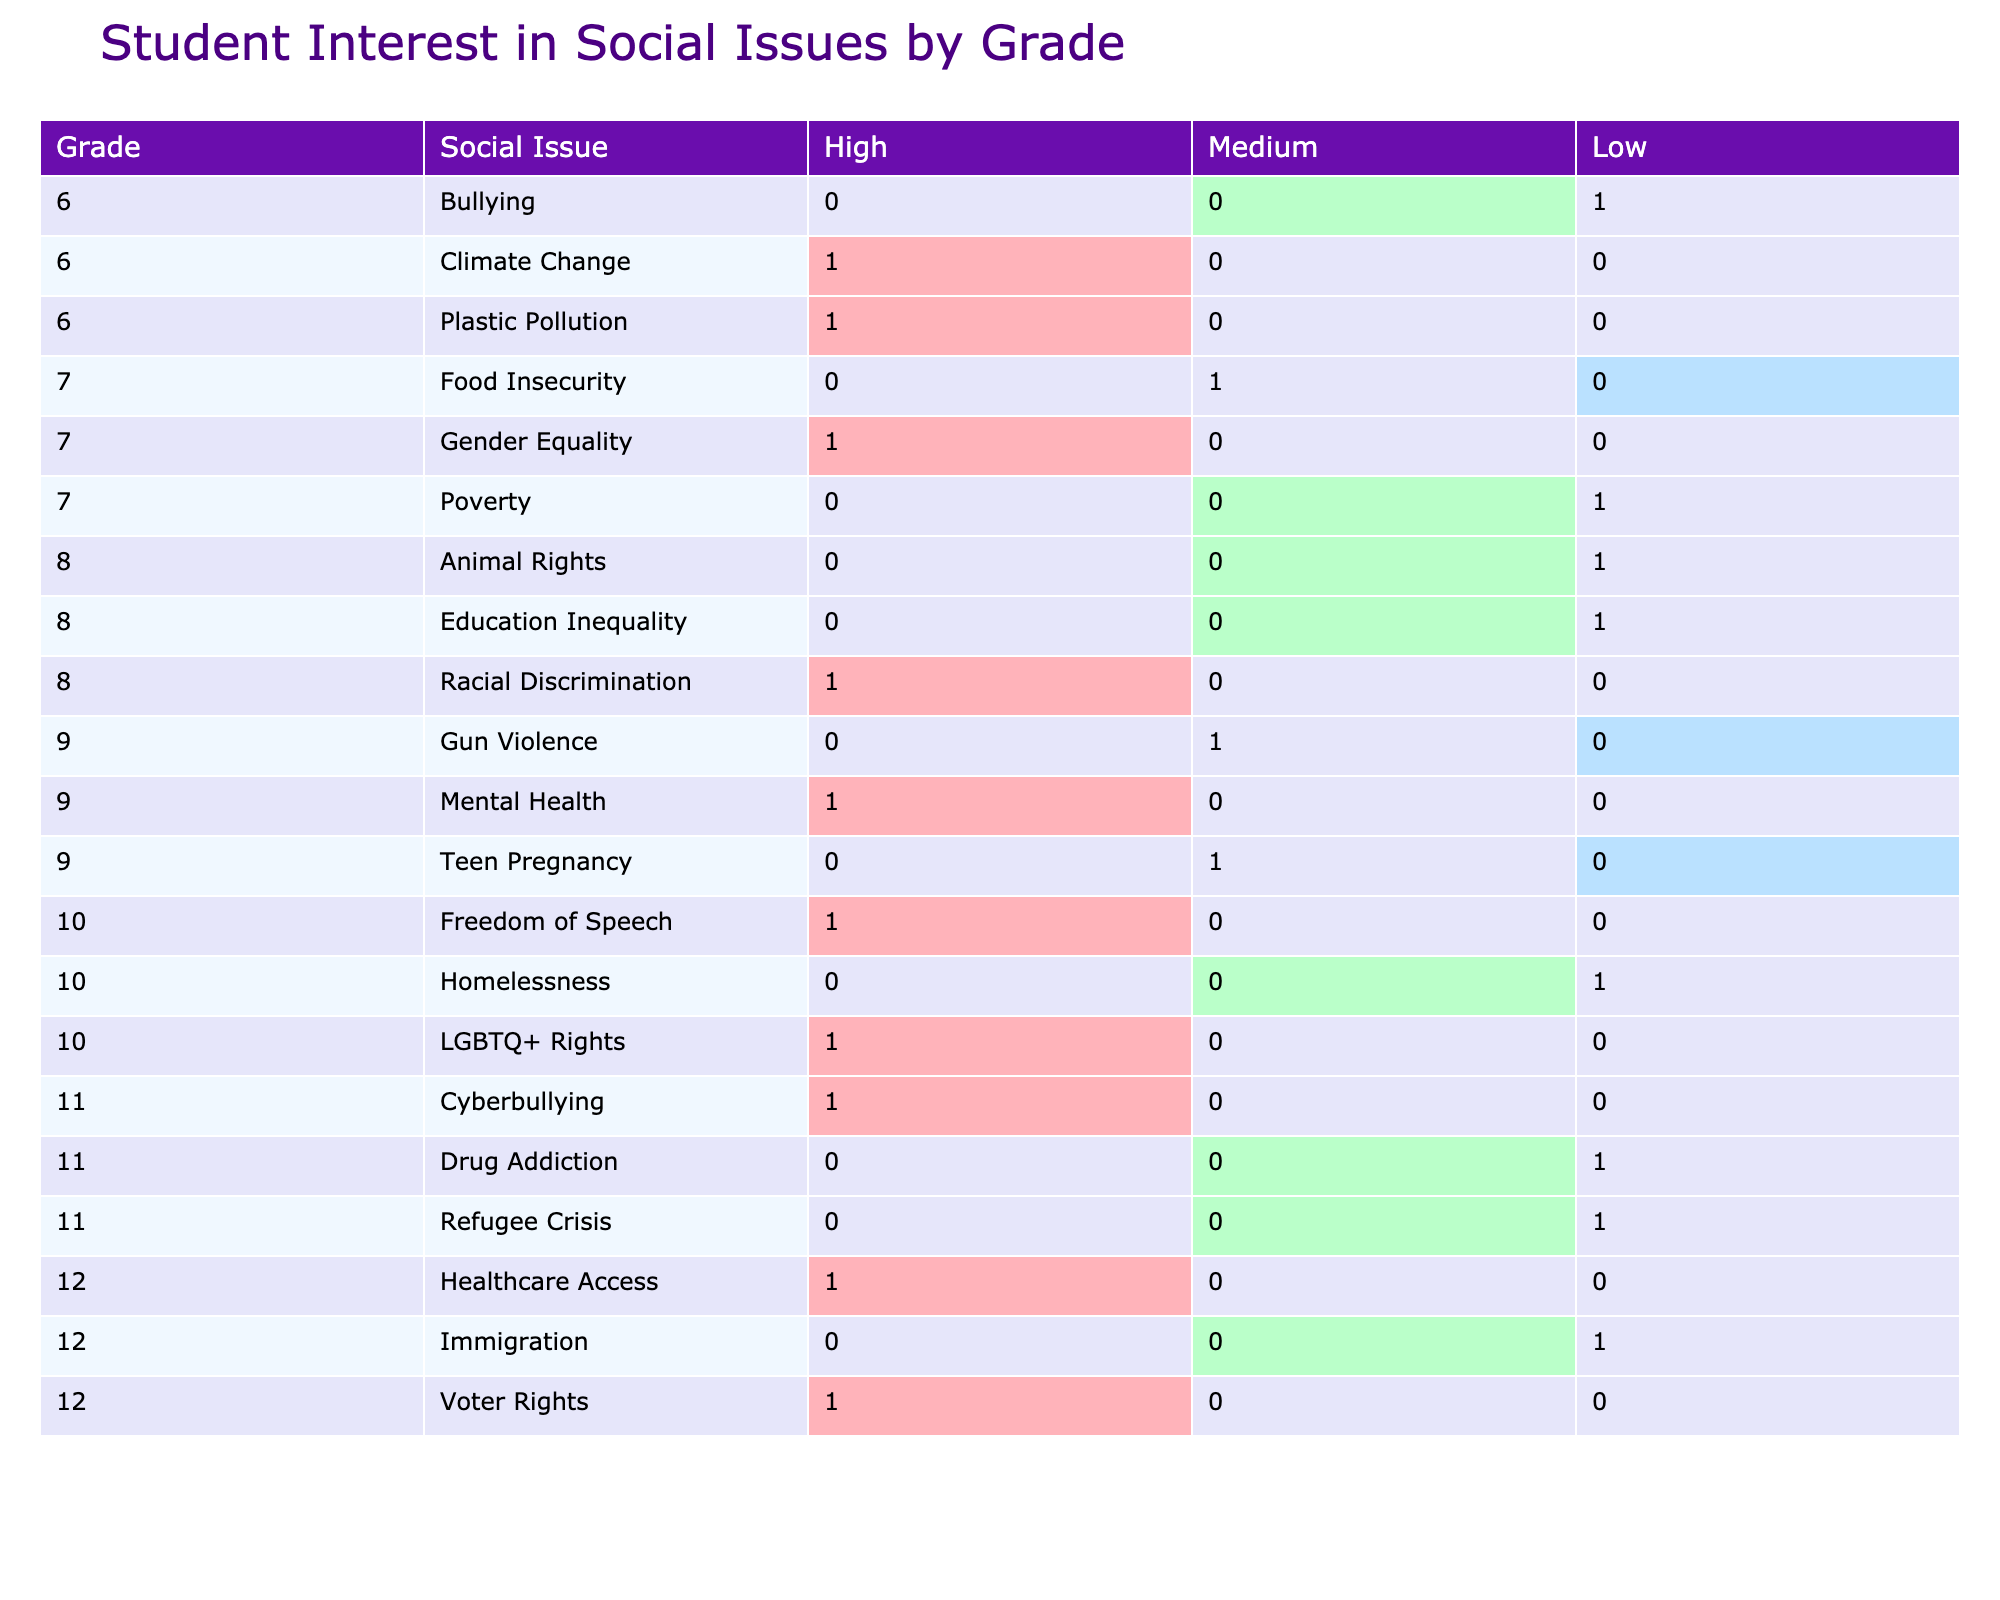What is the total number of students interested in "Gender Equality"? In the table, we see the row for "Gender Equality" under grade 7. Looking at the respective columns, we can see there are 2 students interested at the "High" level and 0 students at the "Medium" and "Low" levels. Therefore, the total number of students interested in "Gender Equality" is 2.
Answer: 2 Which social issue under grade 10 has the highest interest level? In the grade 10 section, we review the social issues listed: "LGBTQ+ Rights" has 1 student with "High" interest, "Homelessness" has 0 students with "High" interest, and "Freedom of Speech" has 1 student with "High" interest. Thus, both "LGBTQ+ Rights" and "Freedom of Speech" share the highest interest level, with a total of 1 each at the "High" level.
Answer: LGBTQ+ Rights and Freedom of Speech How many students in grade 8 expressed a "Low" interest in social issues? In the table under grade 8, we check for any entries with the "Low" interest level. The only entry is for "Animal Rights" with 0 students, “Racial Discrimination” has 0 students, and "Education Inequality" has 0 students as well. Therefore, there are zero students in grade 8 with a "Low" interest in social issues.
Answer: 0 Is there a social issue in grade 11 that has an "Interest Level" of "Medium"? In grade 11, we review the social issues which are "Drug Addiction" and "Cyberbullying". "Drug Addiction" has 0 students interested at the "Medium" level while "Cyberbullying" has 1 student. Hence, there is indeed a social issue in grade 11 with a "Medium" interest level.
Answer: Yes What is the difference in the number of students with "High" interest between grade 7 and grade 9? For grade 7, the social issues and their "High" interest counts are: "Gender Equality" (2), "Poverty" (0), and the total is 2. For grade 9, we have: "Mental Health" (1), "Gun Violence" (0), "Teen Pregnancy" (0), leading to a total of 1 "High" interest student. The difference in "High" interest students between grade 7 and grade 9 is 2 - 1 = 1.
Answer: 1 